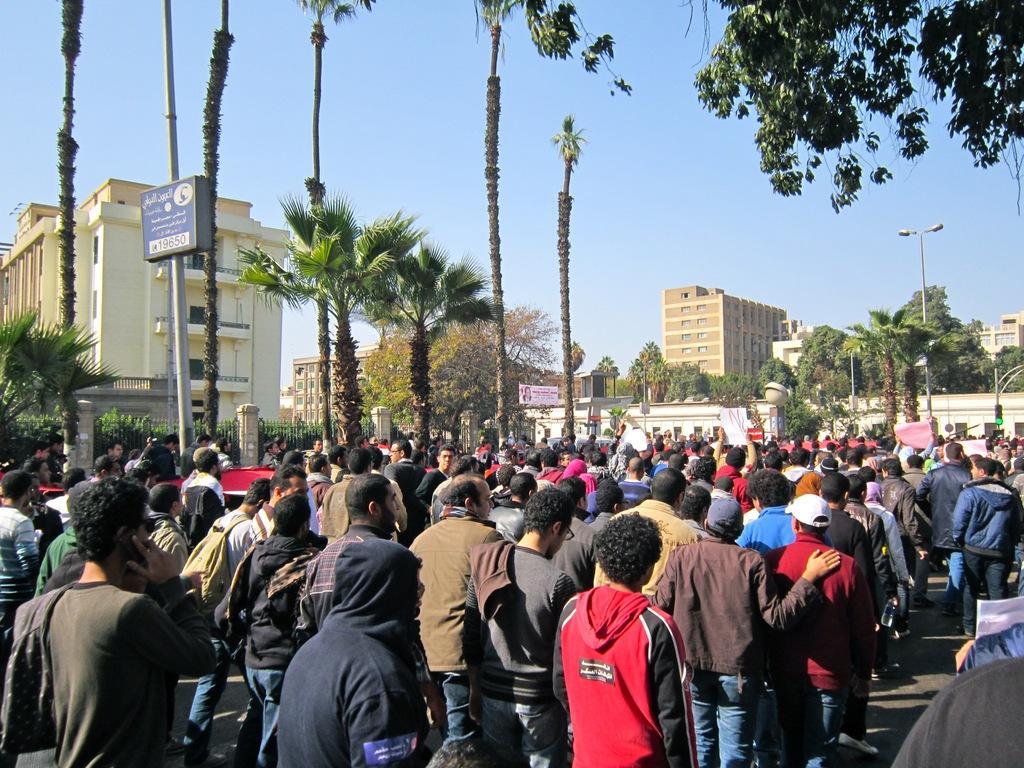In one or two sentences, can you explain what this image depicts? There are group of people standing. Among them few of them are holding placards. These are the trees. I can see the buildings. Here is a banner hanging. This is the street light. Here is a traffic signal, which is attached to the pole. These look like barricades attached to the pillars. 